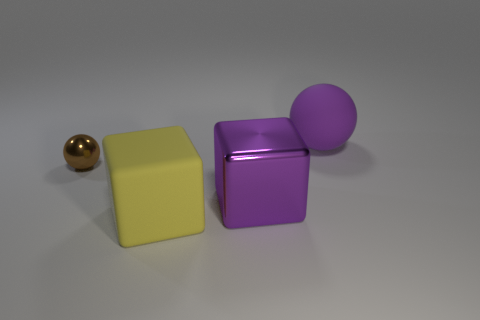Add 4 small shiny cubes. How many objects exist? 8 Subtract 1 yellow cubes. How many objects are left? 3 Subtract all blue balls. Subtract all red cubes. How many balls are left? 2 Subtract all large matte cubes. Subtract all brown balls. How many objects are left? 2 Add 1 brown metal objects. How many brown metal objects are left? 2 Add 4 matte spheres. How many matte spheres exist? 5 